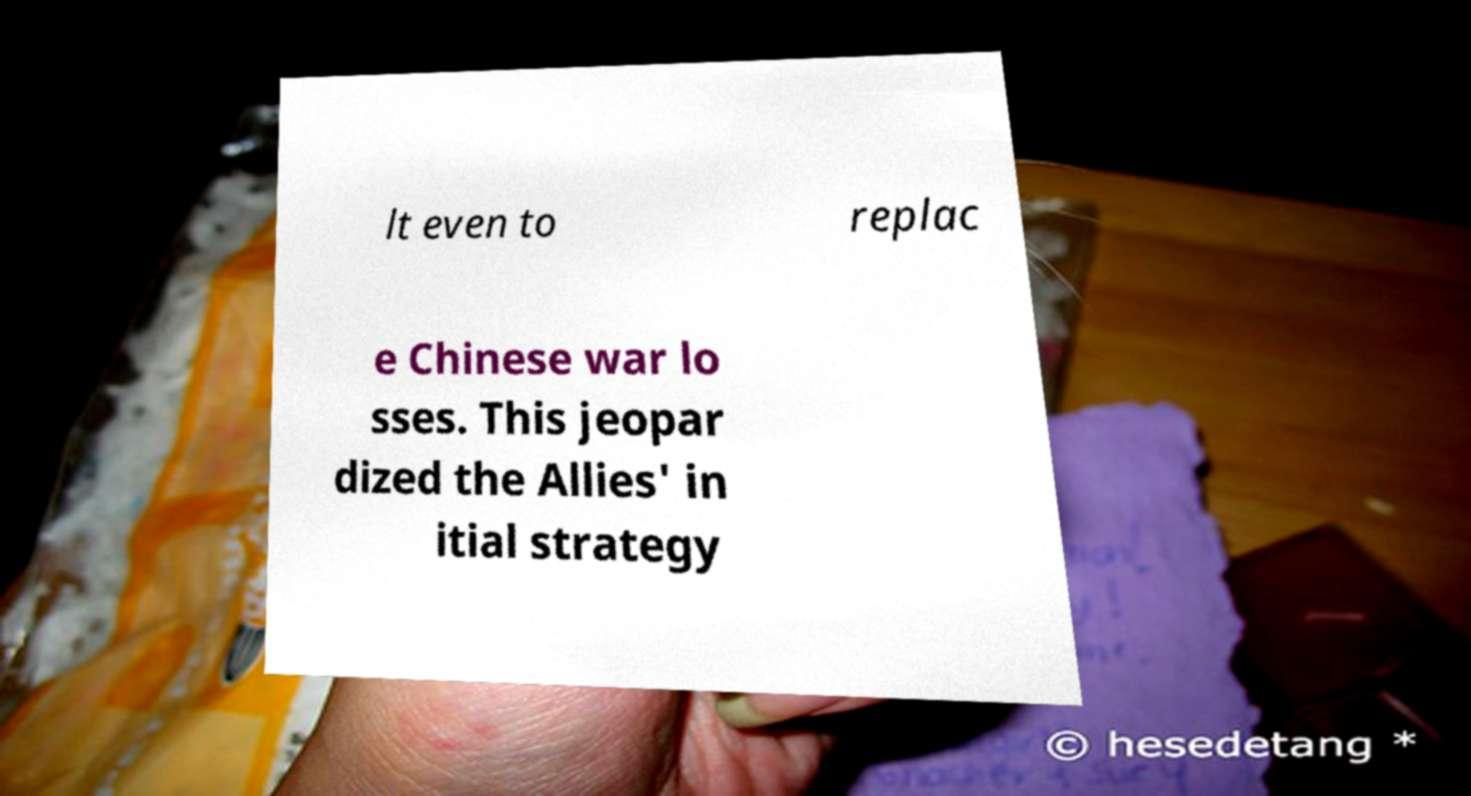There's text embedded in this image that I need extracted. Can you transcribe it verbatim? lt even to replac e Chinese war lo sses. This jeopar dized the Allies' in itial strategy 